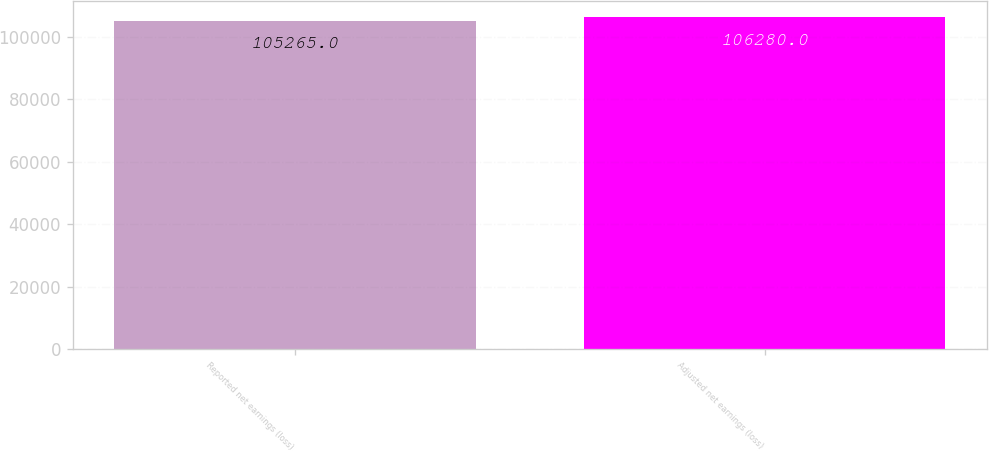Convert chart to OTSL. <chart><loc_0><loc_0><loc_500><loc_500><bar_chart><fcel>Reported net earnings (loss)<fcel>Adjusted net earnings (loss)<nl><fcel>105265<fcel>106280<nl></chart> 